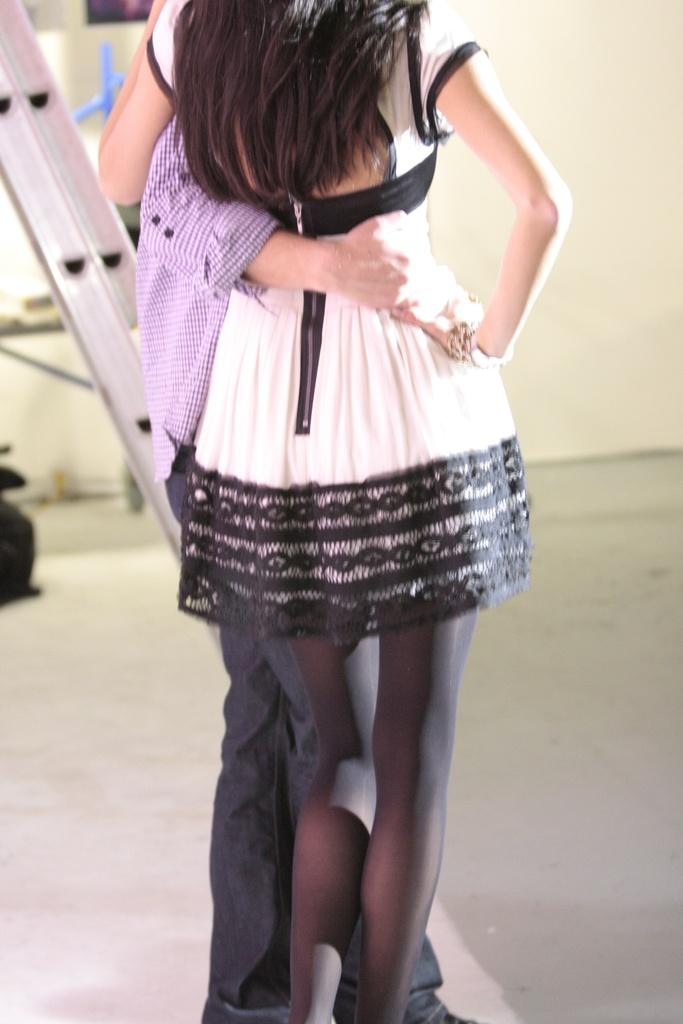Who are the two people in the image? There is a man and a woman in the image. What are the man and woman doing in the image? The man and woman are holding each other. Where are the man and woman standing in the image? They are standing on the floor. What can be seen on the left side of the image? There is a ladder on the left side of the image. What is visible in the background of the image? There is a wall visible in the background of the image. What type of kettle is being used by the maid in the image? There is no kettle or maid present in the image. What game are the man and woman playing in the image? The man and woman are not playing a game in the image; they are holding each other. 